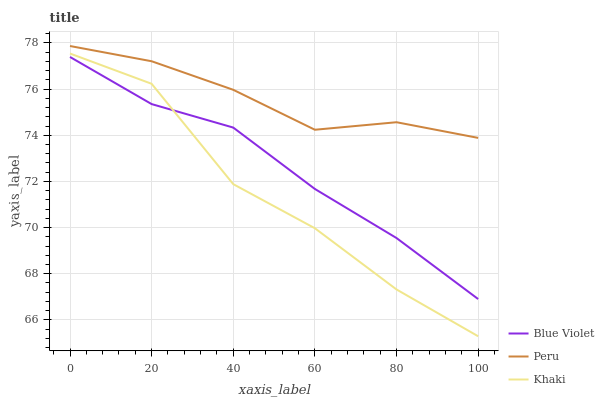Does Khaki have the minimum area under the curve?
Answer yes or no. Yes. Does Peru have the maximum area under the curve?
Answer yes or no. Yes. Does Blue Violet have the minimum area under the curve?
Answer yes or no. No. Does Blue Violet have the maximum area under the curve?
Answer yes or no. No. Is Blue Violet the smoothest?
Answer yes or no. Yes. Is Khaki the roughest?
Answer yes or no. Yes. Is Peru the smoothest?
Answer yes or no. No. Is Peru the roughest?
Answer yes or no. No. Does Khaki have the lowest value?
Answer yes or no. Yes. Does Blue Violet have the lowest value?
Answer yes or no. No. Does Peru have the highest value?
Answer yes or no. Yes. Does Blue Violet have the highest value?
Answer yes or no. No. Is Blue Violet less than Peru?
Answer yes or no. Yes. Is Peru greater than Khaki?
Answer yes or no. Yes. Does Blue Violet intersect Khaki?
Answer yes or no. Yes. Is Blue Violet less than Khaki?
Answer yes or no. No. Is Blue Violet greater than Khaki?
Answer yes or no. No. Does Blue Violet intersect Peru?
Answer yes or no. No. 